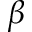<formula> <loc_0><loc_0><loc_500><loc_500>\beta</formula> 